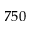Convert formula to latex. <formula><loc_0><loc_0><loc_500><loc_500>7 5 0</formula> 